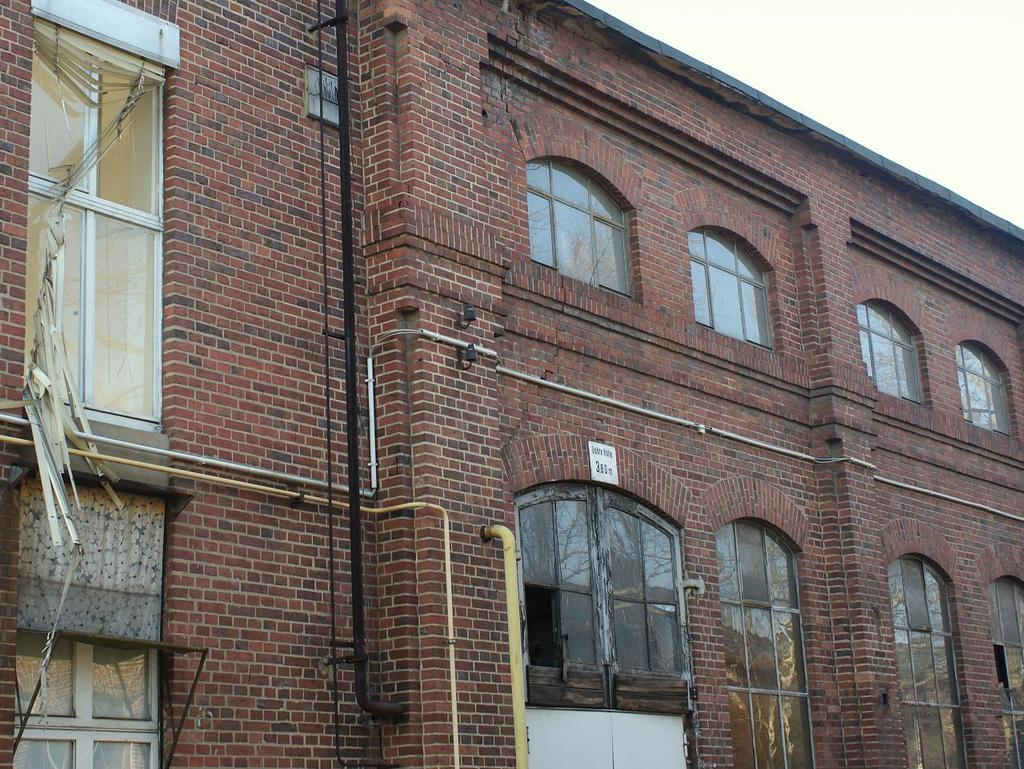What type of structure is present in the image? There is a building in the image. What feature can be observed on the building? The building has glass windows. Can you describe a specific detail about the building's interior? There is a yellow pipe in the middle of the building. What is visible at the top of the image? The sky is visible at the top of the image. What type of oatmeal is being served on the roof of the building in the image? There is no oatmeal present in the image, and the roof of the building is not visible. 